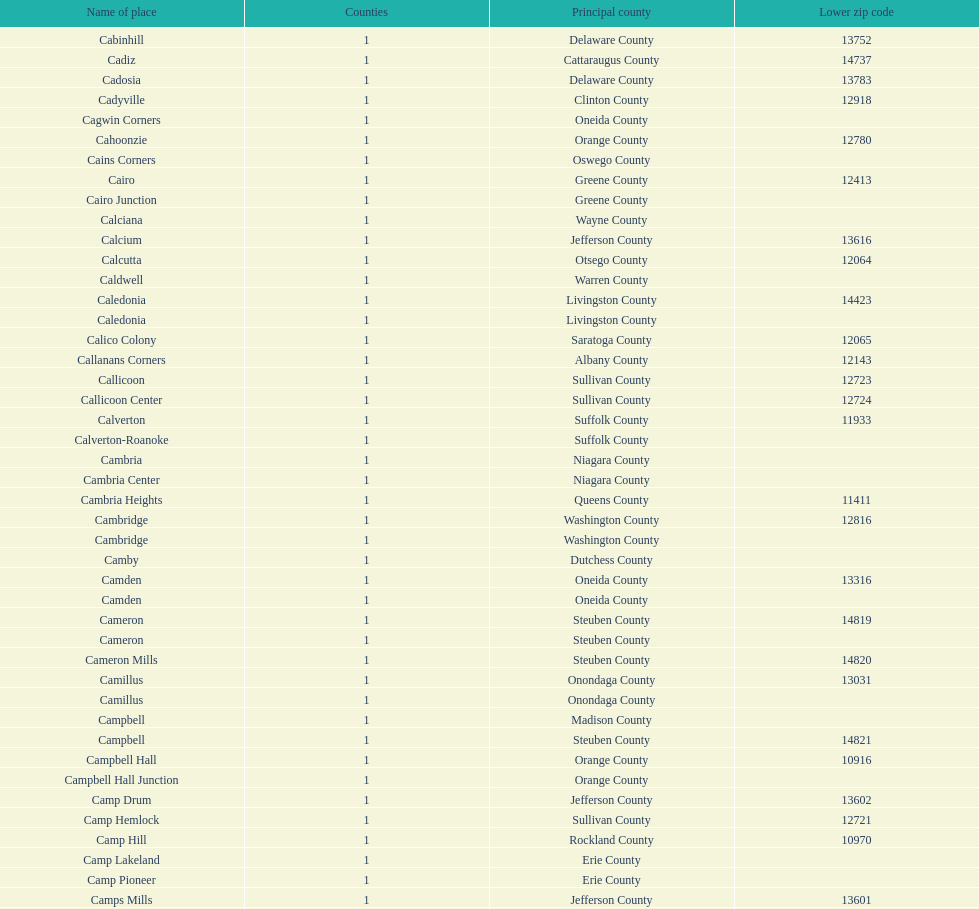What is the number of locations in greene county? 10. 